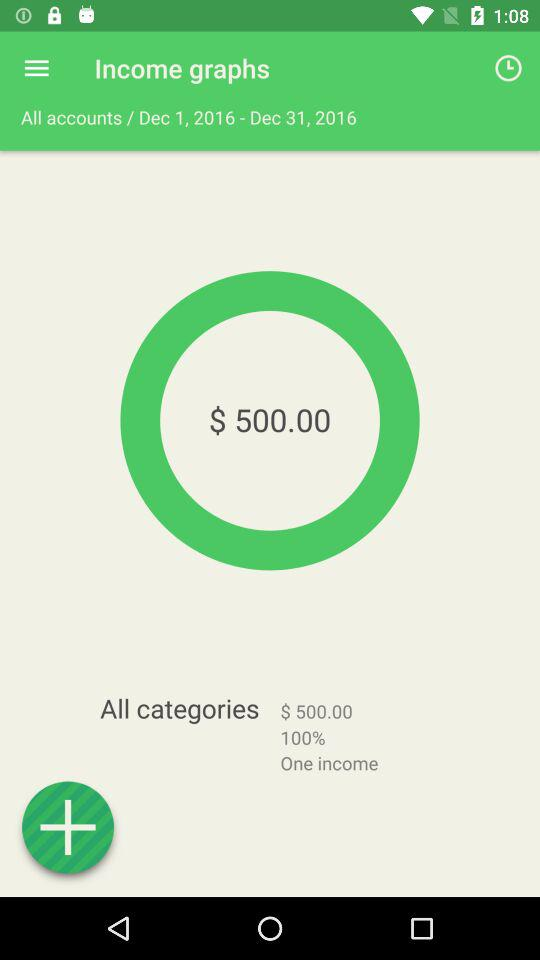What is the total income? The total income is $500. 